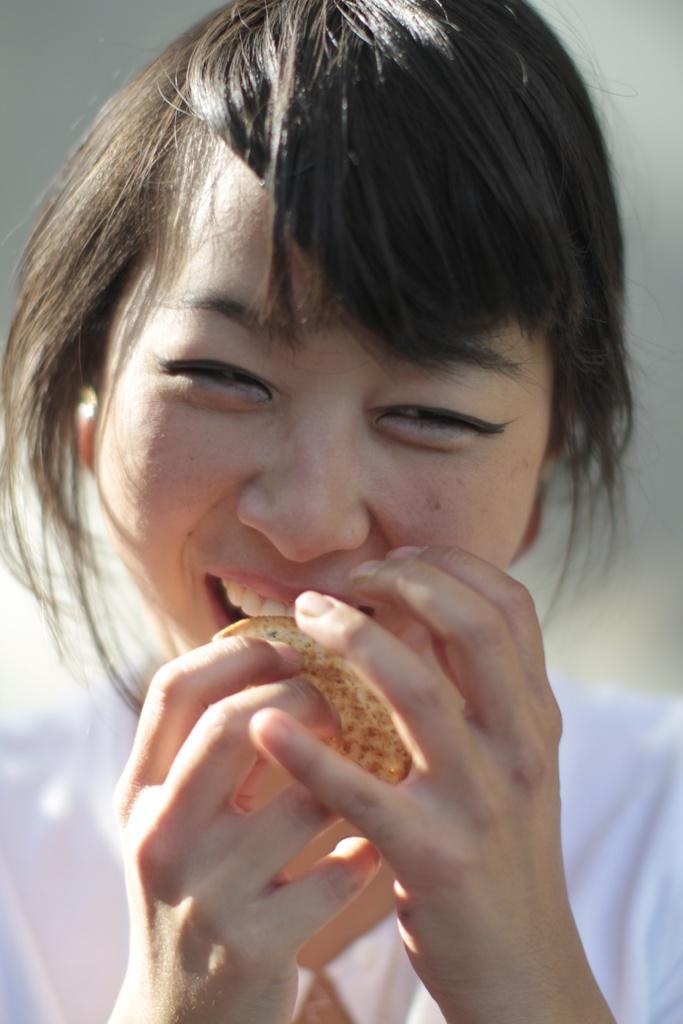Can you describe this image briefly? In this image we can see a woman smiling and holding a food item in her hand. 